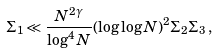<formula> <loc_0><loc_0><loc_500><loc_500>\Sigma _ { 1 } \ll \frac { N ^ { 2 \gamma } } { \log ^ { 4 } N } ( \log \log N ) ^ { 2 } \Sigma _ { 2 } \Sigma _ { 3 } \, ,</formula> 